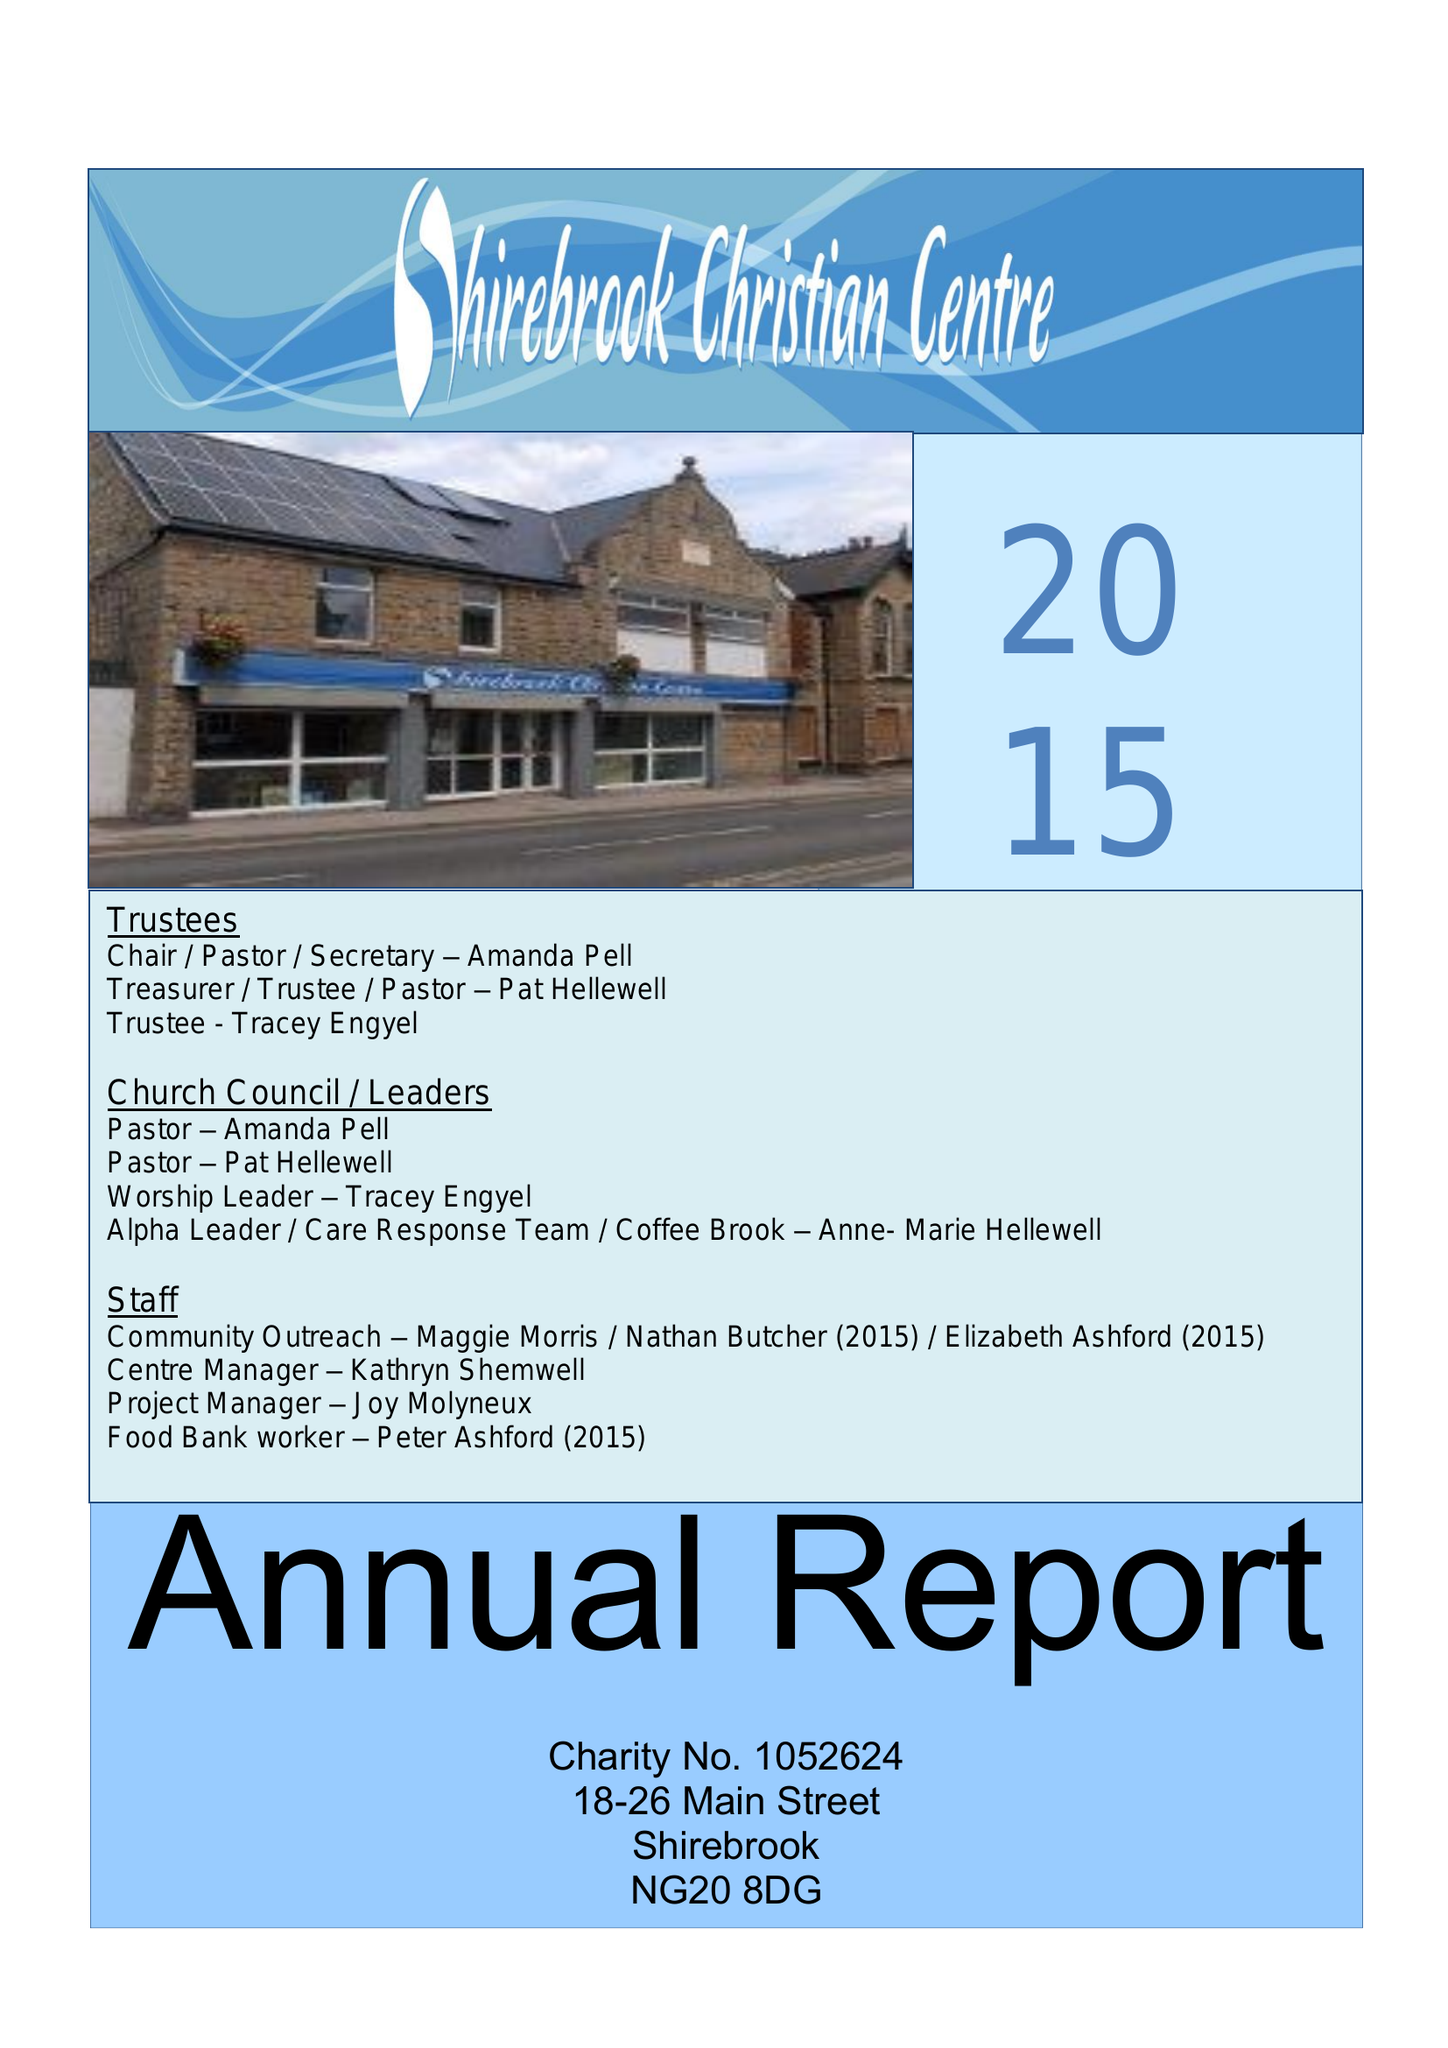What is the value for the charity_name?
Answer the question using a single word or phrase. The Brook Community Church and Centre 